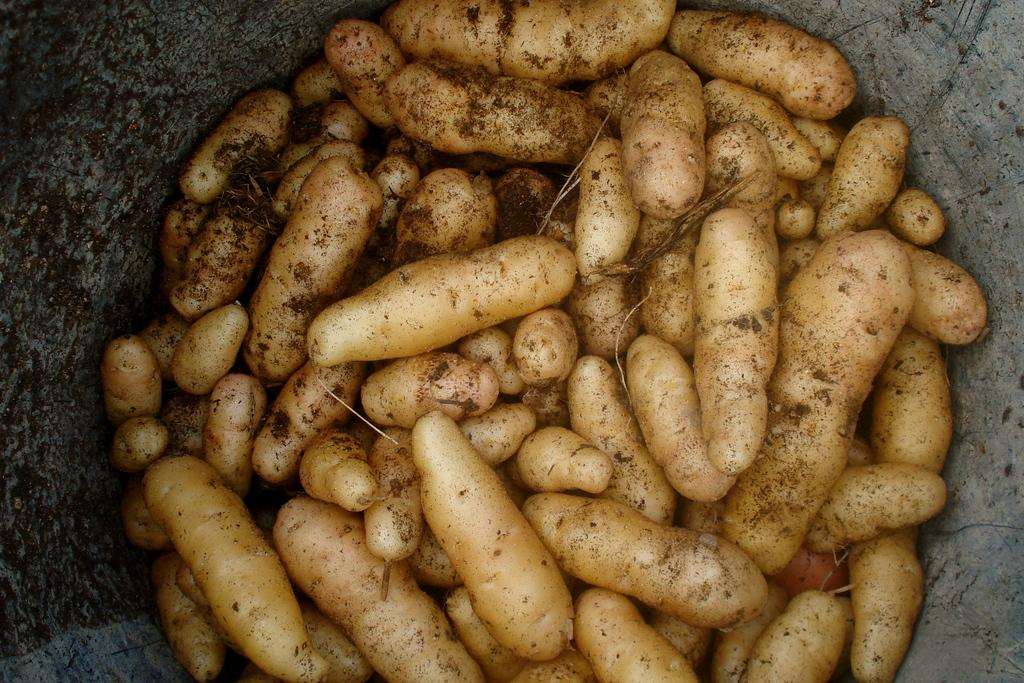What type of vegetable is present in the image? There are potatoes in the image. What type of structure can be seen on both sides of the image? There is a stone wall on the right side of the image and another stone wall on the left side of the image. What type of knowledge can be gained from the potatoes in the image? The potatoes in the image do not convey any specific knowledge. Can you tell me how many buttons are visible on the potatoes in the image? There are no buttons present on the potatoes in the image. 